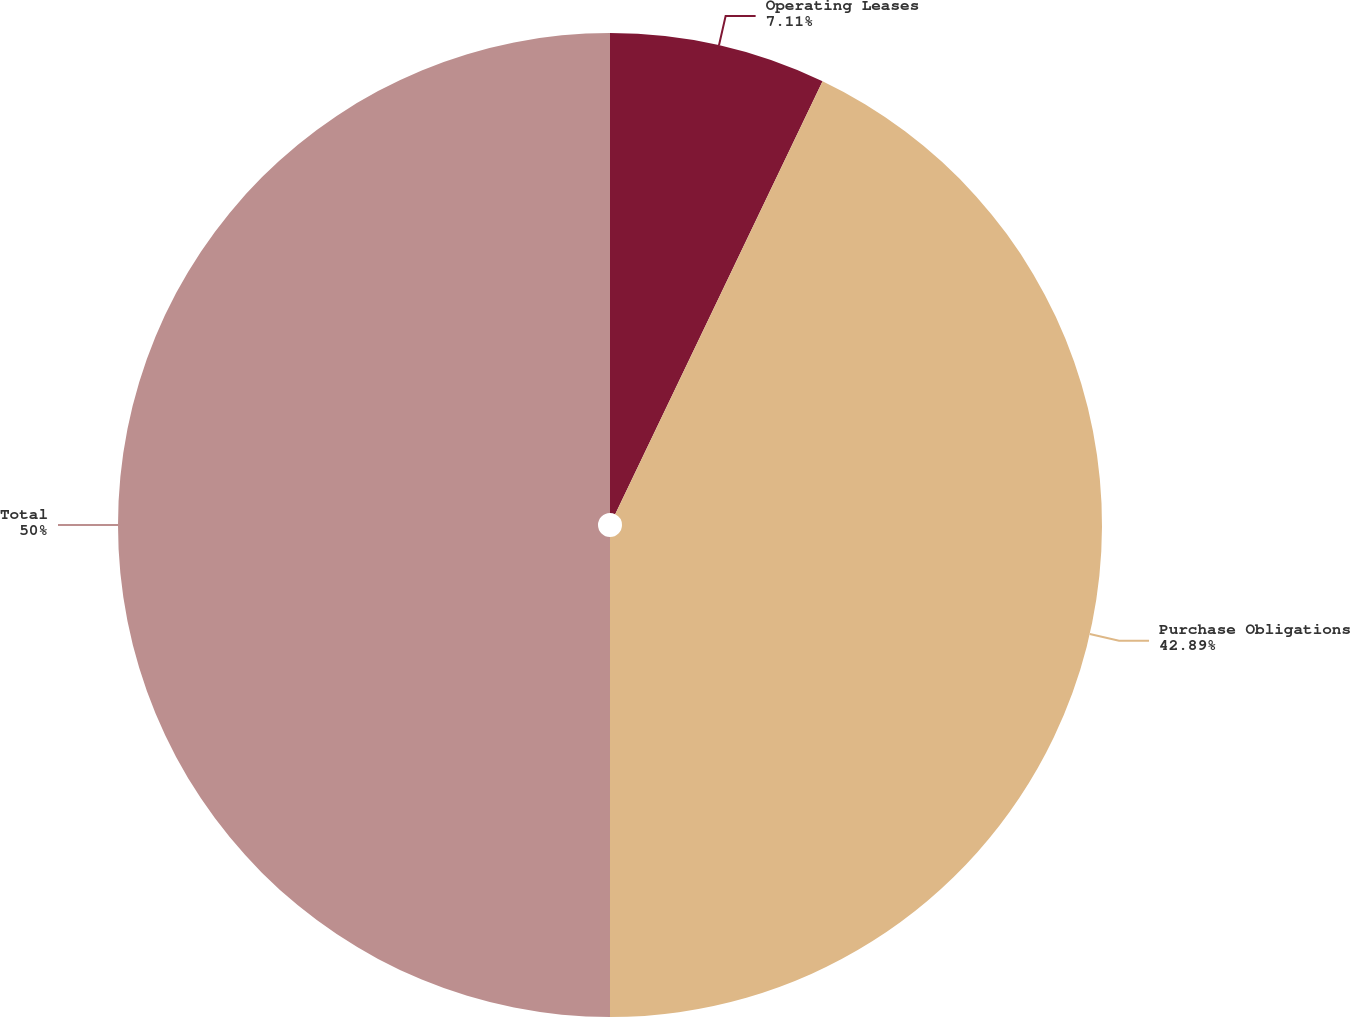Convert chart. <chart><loc_0><loc_0><loc_500><loc_500><pie_chart><fcel>Operating Leases<fcel>Purchase Obligations<fcel>Total<nl><fcel>7.11%<fcel>42.89%<fcel>50.0%<nl></chart> 